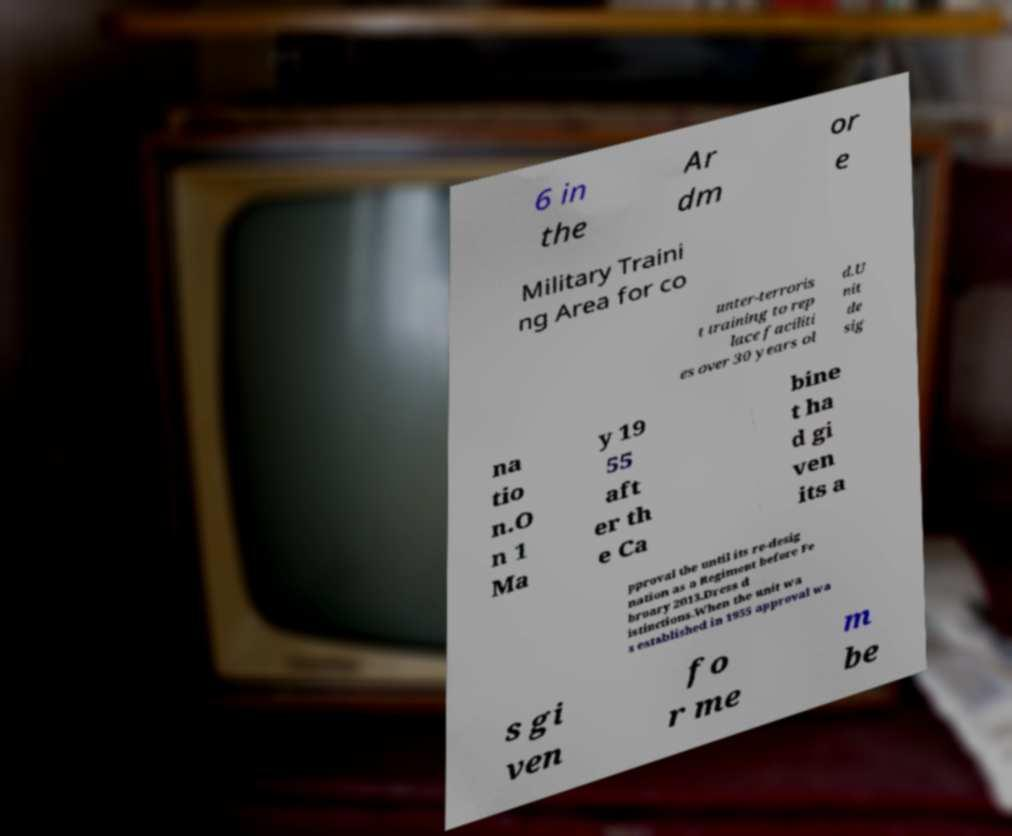Can you accurately transcribe the text from the provided image for me? 6 in the Ar dm or e Military Traini ng Area for co unter-terroris t training to rep lace faciliti es over 30 years ol d.U nit de sig na tio n.O n 1 Ma y 19 55 aft er th e Ca bine t ha d gi ven its a pproval the until its re-desig nation as a Regiment before Fe bruary 2013.Dress d istinctions.When the unit wa s established in 1955 approval wa s gi ven fo r me m be 